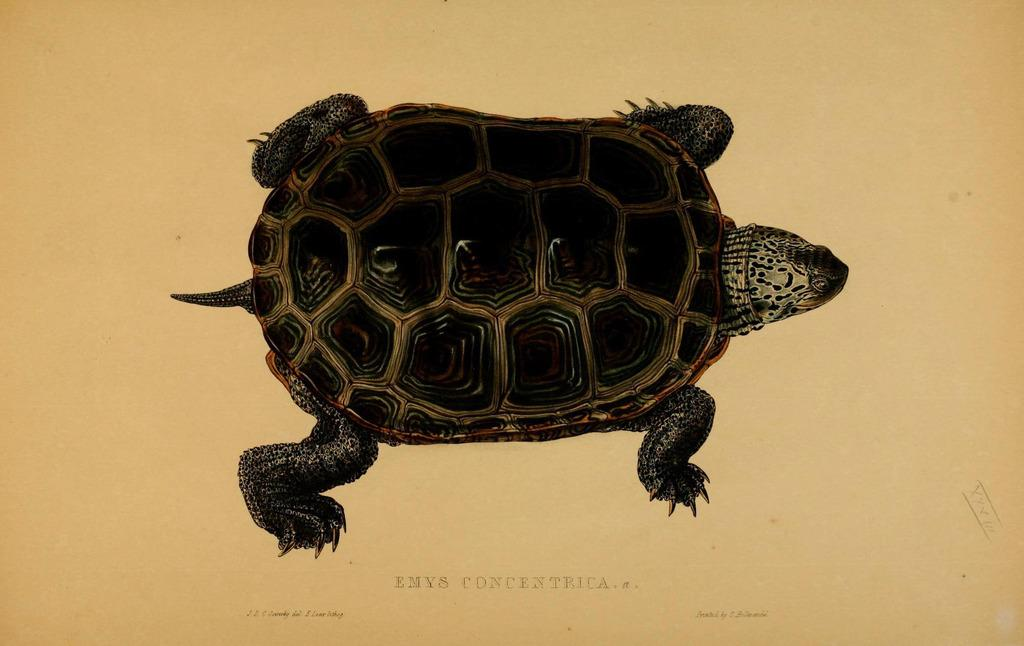What is the main subject in the center of the image? There is a tortoise in the center of the image. What else can be seen at the bottom of the image? There is some text at the bottom of the image. What type of hair can be seen on the tortoise in the image? There is no hair present on the tortoise in the image. What is the likelihood of the tortoise having a chance to win a race in the image? The image does not depict a race or provide any information about the tortoise's abilities, so it is not possible to determine the likelihood of the tortoise having a chance to win a race. 